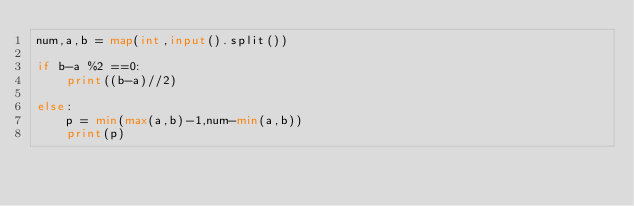<code> <loc_0><loc_0><loc_500><loc_500><_Python_>num,a,b = map(int,input().split())

if b-a %2 ==0:
    print((b-a)//2)

else:
    p = min(max(a,b)-1,num-min(a,b))
    print(p)</code> 